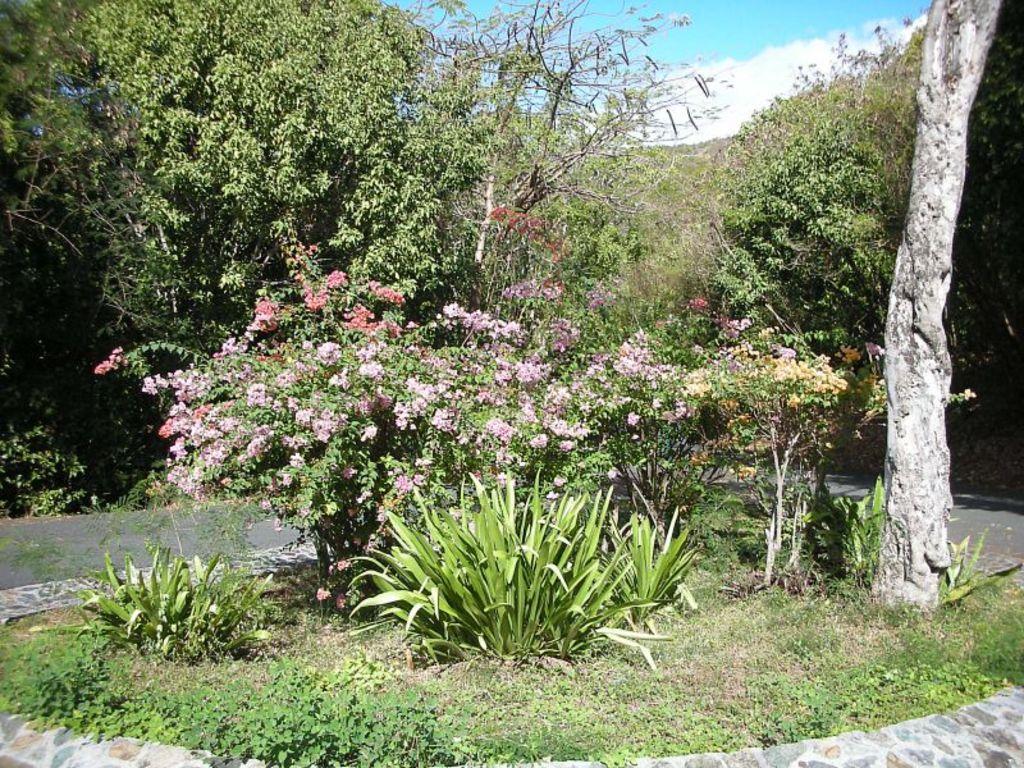In one or two sentences, can you explain what this image depicts? This is an outside view. In the middle of the image there are few plants along with the flowers. In the background there is a road and there are many trees. On the right side there is a tree trunk. At the top of the image I can see the sky and clouds. 